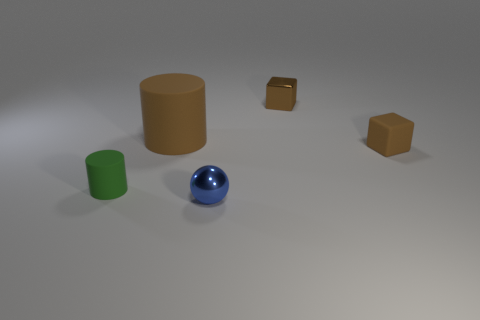Add 4 big rubber cylinders. How many objects exist? 9 Subtract all green cylinders. How many cylinders are left? 1 Subtract all spheres. How many objects are left? 4 Add 1 green cylinders. How many green cylinders exist? 2 Subtract 0 green balls. How many objects are left? 5 Subtract all purple spheres. Subtract all yellow cylinders. How many spheres are left? 1 Subtract all brown rubber things. Subtract all tiny rubber cylinders. How many objects are left? 2 Add 2 green cylinders. How many green cylinders are left? 3 